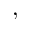<formula> <loc_0><loc_0><loc_500><loc_500>,</formula> 